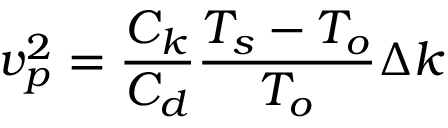<formula> <loc_0><loc_0><loc_500><loc_500>v _ { p } ^ { 2 } = { \frac { C _ { k } } { C _ { d } } } { \frac { T _ { s } - T _ { o } } { T _ { o } } } \Delta k</formula> 